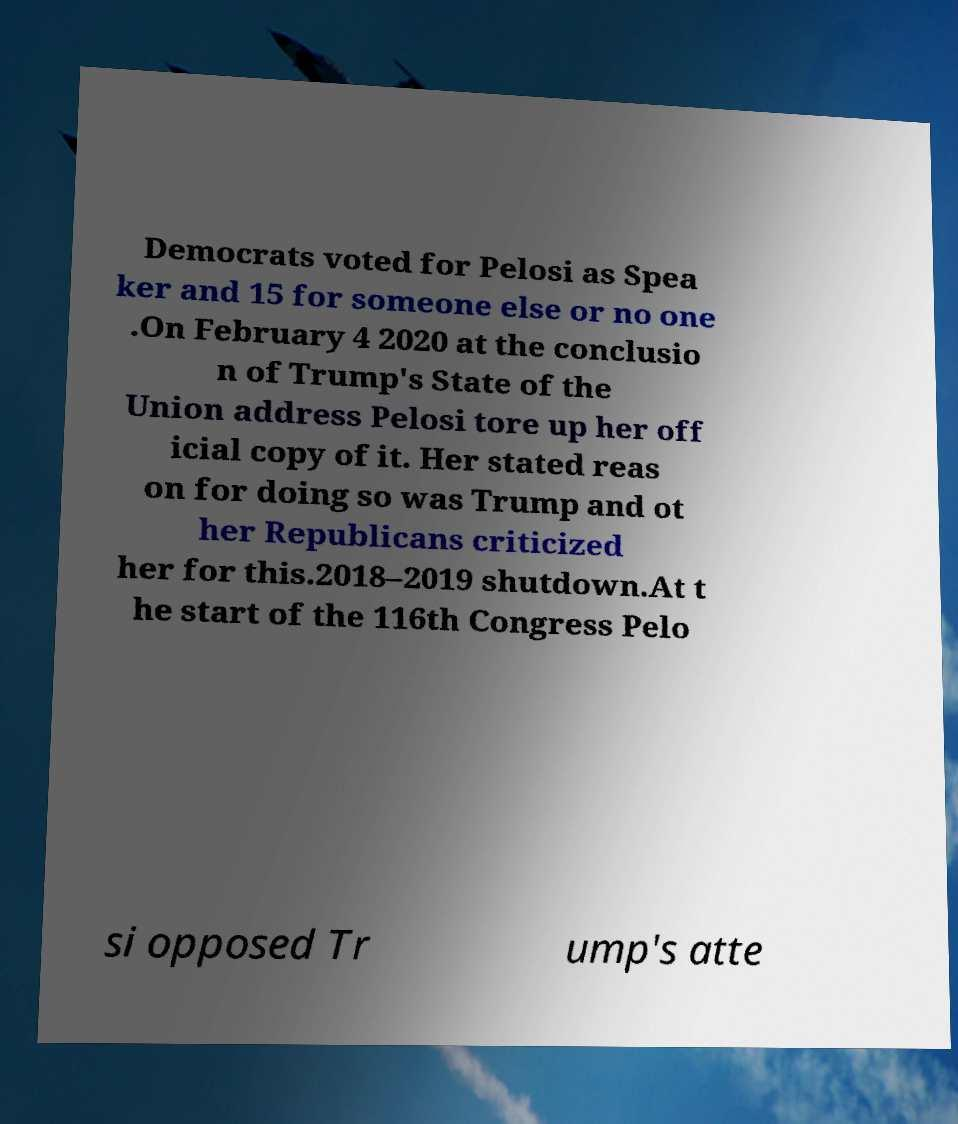Can you read and provide the text displayed in the image?This photo seems to have some interesting text. Can you extract and type it out for me? Democrats voted for Pelosi as Spea ker and 15 for someone else or no one .On February 4 2020 at the conclusio n of Trump's State of the Union address Pelosi tore up her off icial copy of it. Her stated reas on for doing so was Trump and ot her Republicans criticized her for this.2018–2019 shutdown.At t he start of the 116th Congress Pelo si opposed Tr ump's atte 